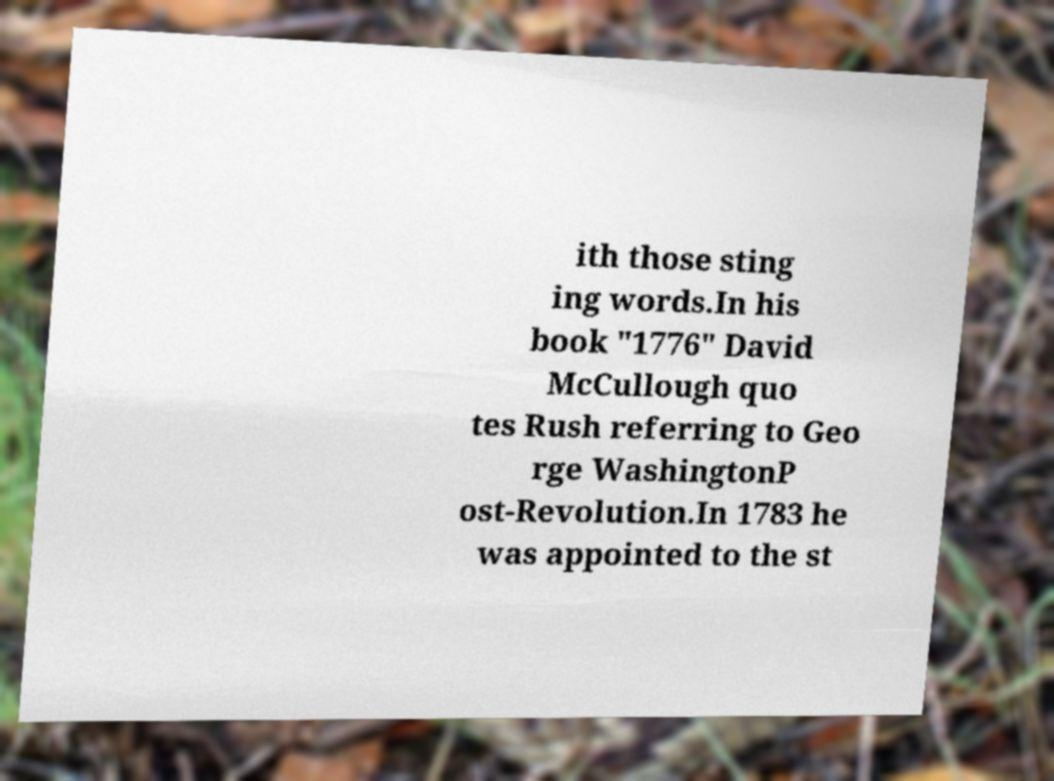For documentation purposes, I need the text within this image transcribed. Could you provide that? ith those sting ing words.In his book "1776" David McCullough quo tes Rush referring to Geo rge WashingtonP ost-Revolution.In 1783 he was appointed to the st 